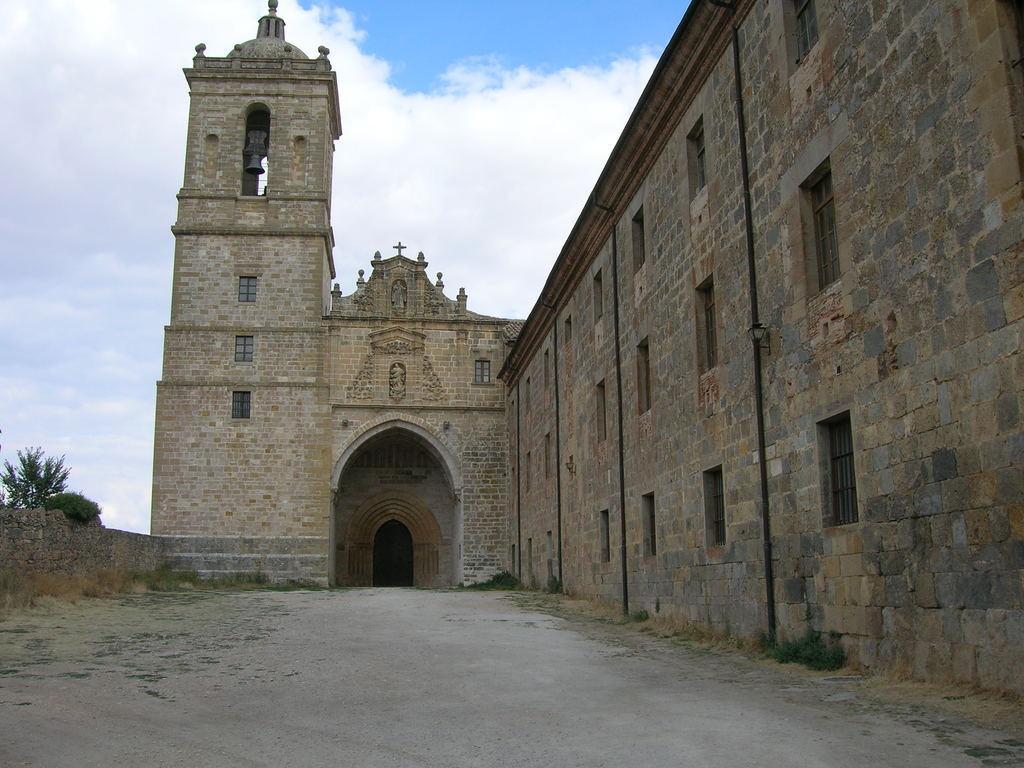Describe this image in one or two sentences. In this image I can see a building in brown color, trees in green color and sky in white and blue color. 